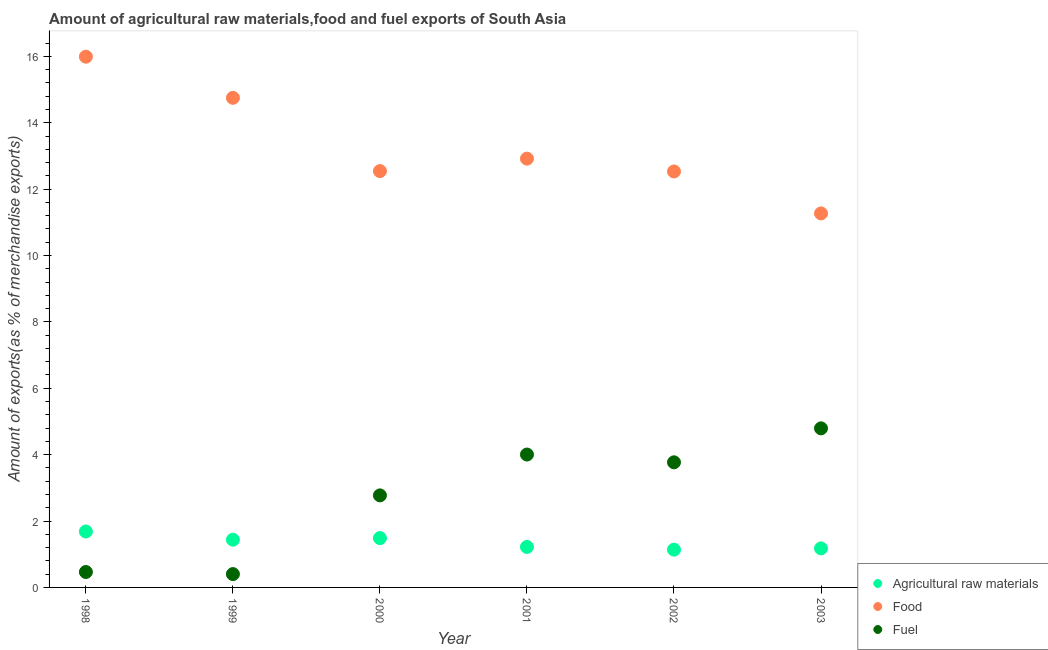Is the number of dotlines equal to the number of legend labels?
Offer a terse response. Yes. What is the percentage of raw materials exports in 2003?
Keep it short and to the point. 1.18. Across all years, what is the maximum percentage of fuel exports?
Provide a succinct answer. 4.79. Across all years, what is the minimum percentage of raw materials exports?
Give a very brief answer. 1.14. In which year was the percentage of fuel exports maximum?
Your response must be concise. 2003. In which year was the percentage of food exports minimum?
Your answer should be compact. 2003. What is the total percentage of raw materials exports in the graph?
Make the answer very short. 8.14. What is the difference between the percentage of food exports in 1998 and that in 2000?
Your response must be concise. 3.45. What is the difference between the percentage of fuel exports in 2001 and the percentage of food exports in 1999?
Your response must be concise. -10.75. What is the average percentage of food exports per year?
Give a very brief answer. 13.33. In the year 2000, what is the difference between the percentage of food exports and percentage of raw materials exports?
Your answer should be very brief. 11.06. In how many years, is the percentage of food exports greater than 14 %?
Keep it short and to the point. 2. What is the ratio of the percentage of fuel exports in 1998 to that in 2000?
Offer a very short reply. 0.17. Is the difference between the percentage of food exports in 1998 and 2001 greater than the difference between the percentage of fuel exports in 1998 and 2001?
Provide a short and direct response. Yes. What is the difference between the highest and the second highest percentage of raw materials exports?
Keep it short and to the point. 0.2. What is the difference between the highest and the lowest percentage of fuel exports?
Make the answer very short. 4.39. In how many years, is the percentage of raw materials exports greater than the average percentage of raw materials exports taken over all years?
Ensure brevity in your answer.  3. Is the sum of the percentage of raw materials exports in 2001 and 2002 greater than the maximum percentage of fuel exports across all years?
Make the answer very short. No. Is it the case that in every year, the sum of the percentage of raw materials exports and percentage of food exports is greater than the percentage of fuel exports?
Your answer should be very brief. Yes. Is the percentage of food exports strictly greater than the percentage of raw materials exports over the years?
Your answer should be very brief. Yes. Is the percentage of fuel exports strictly less than the percentage of food exports over the years?
Your answer should be very brief. Yes. How many dotlines are there?
Provide a succinct answer. 3. How many years are there in the graph?
Provide a short and direct response. 6. What is the difference between two consecutive major ticks on the Y-axis?
Provide a succinct answer. 2. Are the values on the major ticks of Y-axis written in scientific E-notation?
Your answer should be compact. No. Does the graph contain any zero values?
Provide a succinct answer. No. Where does the legend appear in the graph?
Provide a succinct answer. Bottom right. How many legend labels are there?
Provide a short and direct response. 3. What is the title of the graph?
Your answer should be very brief. Amount of agricultural raw materials,food and fuel exports of South Asia. What is the label or title of the Y-axis?
Your answer should be very brief. Amount of exports(as % of merchandise exports). What is the Amount of exports(as % of merchandise exports) in Agricultural raw materials in 1998?
Your response must be concise. 1.68. What is the Amount of exports(as % of merchandise exports) of Food in 1998?
Keep it short and to the point. 15.99. What is the Amount of exports(as % of merchandise exports) of Fuel in 1998?
Provide a succinct answer. 0.46. What is the Amount of exports(as % of merchandise exports) in Agricultural raw materials in 1999?
Provide a short and direct response. 1.44. What is the Amount of exports(as % of merchandise exports) of Food in 1999?
Your answer should be compact. 14.75. What is the Amount of exports(as % of merchandise exports) in Fuel in 1999?
Offer a very short reply. 0.4. What is the Amount of exports(as % of merchandise exports) of Agricultural raw materials in 2000?
Offer a terse response. 1.49. What is the Amount of exports(as % of merchandise exports) in Food in 2000?
Provide a succinct answer. 12.54. What is the Amount of exports(as % of merchandise exports) in Fuel in 2000?
Ensure brevity in your answer.  2.77. What is the Amount of exports(as % of merchandise exports) in Agricultural raw materials in 2001?
Your answer should be very brief. 1.22. What is the Amount of exports(as % of merchandise exports) of Food in 2001?
Your answer should be very brief. 12.92. What is the Amount of exports(as % of merchandise exports) of Fuel in 2001?
Provide a succinct answer. 4. What is the Amount of exports(as % of merchandise exports) of Agricultural raw materials in 2002?
Offer a very short reply. 1.14. What is the Amount of exports(as % of merchandise exports) in Food in 2002?
Make the answer very short. 12.53. What is the Amount of exports(as % of merchandise exports) in Fuel in 2002?
Ensure brevity in your answer.  3.77. What is the Amount of exports(as % of merchandise exports) in Agricultural raw materials in 2003?
Your answer should be very brief. 1.18. What is the Amount of exports(as % of merchandise exports) of Food in 2003?
Offer a very short reply. 11.27. What is the Amount of exports(as % of merchandise exports) in Fuel in 2003?
Keep it short and to the point. 4.79. Across all years, what is the maximum Amount of exports(as % of merchandise exports) in Agricultural raw materials?
Provide a short and direct response. 1.68. Across all years, what is the maximum Amount of exports(as % of merchandise exports) of Food?
Offer a very short reply. 15.99. Across all years, what is the maximum Amount of exports(as % of merchandise exports) in Fuel?
Your answer should be compact. 4.79. Across all years, what is the minimum Amount of exports(as % of merchandise exports) of Agricultural raw materials?
Offer a terse response. 1.14. Across all years, what is the minimum Amount of exports(as % of merchandise exports) in Food?
Keep it short and to the point. 11.27. Across all years, what is the minimum Amount of exports(as % of merchandise exports) in Fuel?
Ensure brevity in your answer.  0.4. What is the total Amount of exports(as % of merchandise exports) in Agricultural raw materials in the graph?
Keep it short and to the point. 8.14. What is the total Amount of exports(as % of merchandise exports) of Food in the graph?
Make the answer very short. 80. What is the total Amount of exports(as % of merchandise exports) in Fuel in the graph?
Provide a short and direct response. 16.2. What is the difference between the Amount of exports(as % of merchandise exports) of Agricultural raw materials in 1998 and that in 1999?
Your answer should be compact. 0.25. What is the difference between the Amount of exports(as % of merchandise exports) in Food in 1998 and that in 1999?
Make the answer very short. 1.24. What is the difference between the Amount of exports(as % of merchandise exports) in Fuel in 1998 and that in 1999?
Keep it short and to the point. 0.06. What is the difference between the Amount of exports(as % of merchandise exports) of Agricultural raw materials in 1998 and that in 2000?
Make the answer very short. 0.2. What is the difference between the Amount of exports(as % of merchandise exports) in Food in 1998 and that in 2000?
Make the answer very short. 3.45. What is the difference between the Amount of exports(as % of merchandise exports) in Fuel in 1998 and that in 2000?
Give a very brief answer. -2.31. What is the difference between the Amount of exports(as % of merchandise exports) in Agricultural raw materials in 1998 and that in 2001?
Ensure brevity in your answer.  0.47. What is the difference between the Amount of exports(as % of merchandise exports) of Food in 1998 and that in 2001?
Give a very brief answer. 3.07. What is the difference between the Amount of exports(as % of merchandise exports) of Fuel in 1998 and that in 2001?
Your response must be concise. -3.54. What is the difference between the Amount of exports(as % of merchandise exports) of Agricultural raw materials in 1998 and that in 2002?
Ensure brevity in your answer.  0.55. What is the difference between the Amount of exports(as % of merchandise exports) in Food in 1998 and that in 2002?
Ensure brevity in your answer.  3.46. What is the difference between the Amount of exports(as % of merchandise exports) of Fuel in 1998 and that in 2002?
Offer a terse response. -3.3. What is the difference between the Amount of exports(as % of merchandise exports) of Agricultural raw materials in 1998 and that in 2003?
Provide a succinct answer. 0.51. What is the difference between the Amount of exports(as % of merchandise exports) in Food in 1998 and that in 2003?
Give a very brief answer. 4.72. What is the difference between the Amount of exports(as % of merchandise exports) of Fuel in 1998 and that in 2003?
Your answer should be compact. -4.33. What is the difference between the Amount of exports(as % of merchandise exports) of Agricultural raw materials in 1999 and that in 2000?
Provide a succinct answer. -0.05. What is the difference between the Amount of exports(as % of merchandise exports) of Food in 1999 and that in 2000?
Keep it short and to the point. 2.21. What is the difference between the Amount of exports(as % of merchandise exports) of Fuel in 1999 and that in 2000?
Offer a terse response. -2.37. What is the difference between the Amount of exports(as % of merchandise exports) in Agricultural raw materials in 1999 and that in 2001?
Make the answer very short. 0.22. What is the difference between the Amount of exports(as % of merchandise exports) in Food in 1999 and that in 2001?
Keep it short and to the point. 1.83. What is the difference between the Amount of exports(as % of merchandise exports) of Fuel in 1999 and that in 2001?
Ensure brevity in your answer.  -3.6. What is the difference between the Amount of exports(as % of merchandise exports) of Agricultural raw materials in 1999 and that in 2002?
Keep it short and to the point. 0.3. What is the difference between the Amount of exports(as % of merchandise exports) of Food in 1999 and that in 2002?
Provide a short and direct response. 2.22. What is the difference between the Amount of exports(as % of merchandise exports) in Fuel in 1999 and that in 2002?
Ensure brevity in your answer.  -3.37. What is the difference between the Amount of exports(as % of merchandise exports) in Agricultural raw materials in 1999 and that in 2003?
Provide a short and direct response. 0.26. What is the difference between the Amount of exports(as % of merchandise exports) in Food in 1999 and that in 2003?
Provide a short and direct response. 3.48. What is the difference between the Amount of exports(as % of merchandise exports) of Fuel in 1999 and that in 2003?
Offer a very short reply. -4.39. What is the difference between the Amount of exports(as % of merchandise exports) of Agricultural raw materials in 2000 and that in 2001?
Ensure brevity in your answer.  0.27. What is the difference between the Amount of exports(as % of merchandise exports) of Food in 2000 and that in 2001?
Offer a very short reply. -0.37. What is the difference between the Amount of exports(as % of merchandise exports) of Fuel in 2000 and that in 2001?
Make the answer very short. -1.23. What is the difference between the Amount of exports(as % of merchandise exports) in Agricultural raw materials in 2000 and that in 2002?
Make the answer very short. 0.35. What is the difference between the Amount of exports(as % of merchandise exports) of Food in 2000 and that in 2002?
Provide a short and direct response. 0.01. What is the difference between the Amount of exports(as % of merchandise exports) of Fuel in 2000 and that in 2002?
Make the answer very short. -1. What is the difference between the Amount of exports(as % of merchandise exports) in Agricultural raw materials in 2000 and that in 2003?
Keep it short and to the point. 0.31. What is the difference between the Amount of exports(as % of merchandise exports) of Food in 2000 and that in 2003?
Offer a terse response. 1.28. What is the difference between the Amount of exports(as % of merchandise exports) in Fuel in 2000 and that in 2003?
Ensure brevity in your answer.  -2.02. What is the difference between the Amount of exports(as % of merchandise exports) of Agricultural raw materials in 2001 and that in 2002?
Give a very brief answer. 0.08. What is the difference between the Amount of exports(as % of merchandise exports) in Food in 2001 and that in 2002?
Offer a terse response. 0.39. What is the difference between the Amount of exports(as % of merchandise exports) in Fuel in 2001 and that in 2002?
Your response must be concise. 0.23. What is the difference between the Amount of exports(as % of merchandise exports) of Agricultural raw materials in 2001 and that in 2003?
Provide a short and direct response. 0.04. What is the difference between the Amount of exports(as % of merchandise exports) in Food in 2001 and that in 2003?
Provide a short and direct response. 1.65. What is the difference between the Amount of exports(as % of merchandise exports) of Fuel in 2001 and that in 2003?
Keep it short and to the point. -0.79. What is the difference between the Amount of exports(as % of merchandise exports) in Agricultural raw materials in 2002 and that in 2003?
Offer a terse response. -0.04. What is the difference between the Amount of exports(as % of merchandise exports) in Food in 2002 and that in 2003?
Offer a terse response. 1.26. What is the difference between the Amount of exports(as % of merchandise exports) in Fuel in 2002 and that in 2003?
Your response must be concise. -1.02. What is the difference between the Amount of exports(as % of merchandise exports) of Agricultural raw materials in 1998 and the Amount of exports(as % of merchandise exports) of Food in 1999?
Your response must be concise. -13.07. What is the difference between the Amount of exports(as % of merchandise exports) of Agricultural raw materials in 1998 and the Amount of exports(as % of merchandise exports) of Fuel in 1999?
Your answer should be very brief. 1.28. What is the difference between the Amount of exports(as % of merchandise exports) of Food in 1998 and the Amount of exports(as % of merchandise exports) of Fuel in 1999?
Provide a succinct answer. 15.59. What is the difference between the Amount of exports(as % of merchandise exports) in Agricultural raw materials in 1998 and the Amount of exports(as % of merchandise exports) in Food in 2000?
Provide a succinct answer. -10.86. What is the difference between the Amount of exports(as % of merchandise exports) of Agricultural raw materials in 1998 and the Amount of exports(as % of merchandise exports) of Fuel in 2000?
Offer a very short reply. -1.09. What is the difference between the Amount of exports(as % of merchandise exports) of Food in 1998 and the Amount of exports(as % of merchandise exports) of Fuel in 2000?
Provide a short and direct response. 13.22. What is the difference between the Amount of exports(as % of merchandise exports) of Agricultural raw materials in 1998 and the Amount of exports(as % of merchandise exports) of Food in 2001?
Your answer should be very brief. -11.23. What is the difference between the Amount of exports(as % of merchandise exports) in Agricultural raw materials in 1998 and the Amount of exports(as % of merchandise exports) in Fuel in 2001?
Give a very brief answer. -2.32. What is the difference between the Amount of exports(as % of merchandise exports) in Food in 1998 and the Amount of exports(as % of merchandise exports) in Fuel in 2001?
Give a very brief answer. 11.99. What is the difference between the Amount of exports(as % of merchandise exports) of Agricultural raw materials in 1998 and the Amount of exports(as % of merchandise exports) of Food in 2002?
Keep it short and to the point. -10.85. What is the difference between the Amount of exports(as % of merchandise exports) in Agricultural raw materials in 1998 and the Amount of exports(as % of merchandise exports) in Fuel in 2002?
Your answer should be very brief. -2.08. What is the difference between the Amount of exports(as % of merchandise exports) of Food in 1998 and the Amount of exports(as % of merchandise exports) of Fuel in 2002?
Offer a very short reply. 12.22. What is the difference between the Amount of exports(as % of merchandise exports) of Agricultural raw materials in 1998 and the Amount of exports(as % of merchandise exports) of Food in 2003?
Provide a succinct answer. -9.58. What is the difference between the Amount of exports(as % of merchandise exports) of Agricultural raw materials in 1998 and the Amount of exports(as % of merchandise exports) of Fuel in 2003?
Your response must be concise. -3.11. What is the difference between the Amount of exports(as % of merchandise exports) in Food in 1998 and the Amount of exports(as % of merchandise exports) in Fuel in 2003?
Offer a very short reply. 11.2. What is the difference between the Amount of exports(as % of merchandise exports) of Agricultural raw materials in 1999 and the Amount of exports(as % of merchandise exports) of Food in 2000?
Make the answer very short. -11.1. What is the difference between the Amount of exports(as % of merchandise exports) in Agricultural raw materials in 1999 and the Amount of exports(as % of merchandise exports) in Fuel in 2000?
Offer a terse response. -1.33. What is the difference between the Amount of exports(as % of merchandise exports) in Food in 1999 and the Amount of exports(as % of merchandise exports) in Fuel in 2000?
Provide a succinct answer. 11.98. What is the difference between the Amount of exports(as % of merchandise exports) of Agricultural raw materials in 1999 and the Amount of exports(as % of merchandise exports) of Food in 2001?
Provide a short and direct response. -11.48. What is the difference between the Amount of exports(as % of merchandise exports) of Agricultural raw materials in 1999 and the Amount of exports(as % of merchandise exports) of Fuel in 2001?
Offer a very short reply. -2.56. What is the difference between the Amount of exports(as % of merchandise exports) in Food in 1999 and the Amount of exports(as % of merchandise exports) in Fuel in 2001?
Make the answer very short. 10.75. What is the difference between the Amount of exports(as % of merchandise exports) of Agricultural raw materials in 1999 and the Amount of exports(as % of merchandise exports) of Food in 2002?
Offer a terse response. -11.09. What is the difference between the Amount of exports(as % of merchandise exports) of Agricultural raw materials in 1999 and the Amount of exports(as % of merchandise exports) of Fuel in 2002?
Provide a short and direct response. -2.33. What is the difference between the Amount of exports(as % of merchandise exports) of Food in 1999 and the Amount of exports(as % of merchandise exports) of Fuel in 2002?
Provide a succinct answer. 10.98. What is the difference between the Amount of exports(as % of merchandise exports) of Agricultural raw materials in 1999 and the Amount of exports(as % of merchandise exports) of Food in 2003?
Provide a short and direct response. -9.83. What is the difference between the Amount of exports(as % of merchandise exports) in Agricultural raw materials in 1999 and the Amount of exports(as % of merchandise exports) in Fuel in 2003?
Your answer should be compact. -3.35. What is the difference between the Amount of exports(as % of merchandise exports) in Food in 1999 and the Amount of exports(as % of merchandise exports) in Fuel in 2003?
Provide a succinct answer. 9.96. What is the difference between the Amount of exports(as % of merchandise exports) in Agricultural raw materials in 2000 and the Amount of exports(as % of merchandise exports) in Food in 2001?
Offer a terse response. -11.43. What is the difference between the Amount of exports(as % of merchandise exports) of Agricultural raw materials in 2000 and the Amount of exports(as % of merchandise exports) of Fuel in 2001?
Offer a very short reply. -2.52. What is the difference between the Amount of exports(as % of merchandise exports) in Food in 2000 and the Amount of exports(as % of merchandise exports) in Fuel in 2001?
Provide a short and direct response. 8.54. What is the difference between the Amount of exports(as % of merchandise exports) of Agricultural raw materials in 2000 and the Amount of exports(as % of merchandise exports) of Food in 2002?
Provide a short and direct response. -11.05. What is the difference between the Amount of exports(as % of merchandise exports) of Agricultural raw materials in 2000 and the Amount of exports(as % of merchandise exports) of Fuel in 2002?
Provide a succinct answer. -2.28. What is the difference between the Amount of exports(as % of merchandise exports) in Food in 2000 and the Amount of exports(as % of merchandise exports) in Fuel in 2002?
Provide a succinct answer. 8.77. What is the difference between the Amount of exports(as % of merchandise exports) in Agricultural raw materials in 2000 and the Amount of exports(as % of merchandise exports) in Food in 2003?
Provide a succinct answer. -9.78. What is the difference between the Amount of exports(as % of merchandise exports) of Agricultural raw materials in 2000 and the Amount of exports(as % of merchandise exports) of Fuel in 2003?
Your response must be concise. -3.31. What is the difference between the Amount of exports(as % of merchandise exports) in Food in 2000 and the Amount of exports(as % of merchandise exports) in Fuel in 2003?
Offer a very short reply. 7.75. What is the difference between the Amount of exports(as % of merchandise exports) of Agricultural raw materials in 2001 and the Amount of exports(as % of merchandise exports) of Food in 2002?
Keep it short and to the point. -11.31. What is the difference between the Amount of exports(as % of merchandise exports) in Agricultural raw materials in 2001 and the Amount of exports(as % of merchandise exports) in Fuel in 2002?
Offer a very short reply. -2.55. What is the difference between the Amount of exports(as % of merchandise exports) in Food in 2001 and the Amount of exports(as % of merchandise exports) in Fuel in 2002?
Make the answer very short. 9.15. What is the difference between the Amount of exports(as % of merchandise exports) in Agricultural raw materials in 2001 and the Amount of exports(as % of merchandise exports) in Food in 2003?
Ensure brevity in your answer.  -10.05. What is the difference between the Amount of exports(as % of merchandise exports) in Agricultural raw materials in 2001 and the Amount of exports(as % of merchandise exports) in Fuel in 2003?
Give a very brief answer. -3.57. What is the difference between the Amount of exports(as % of merchandise exports) in Food in 2001 and the Amount of exports(as % of merchandise exports) in Fuel in 2003?
Your response must be concise. 8.13. What is the difference between the Amount of exports(as % of merchandise exports) of Agricultural raw materials in 2002 and the Amount of exports(as % of merchandise exports) of Food in 2003?
Provide a short and direct response. -10.13. What is the difference between the Amount of exports(as % of merchandise exports) in Agricultural raw materials in 2002 and the Amount of exports(as % of merchandise exports) in Fuel in 2003?
Offer a terse response. -3.65. What is the difference between the Amount of exports(as % of merchandise exports) in Food in 2002 and the Amount of exports(as % of merchandise exports) in Fuel in 2003?
Provide a succinct answer. 7.74. What is the average Amount of exports(as % of merchandise exports) of Agricultural raw materials per year?
Provide a short and direct response. 1.36. What is the average Amount of exports(as % of merchandise exports) in Food per year?
Ensure brevity in your answer.  13.33. What is the average Amount of exports(as % of merchandise exports) in Fuel per year?
Offer a terse response. 2.7. In the year 1998, what is the difference between the Amount of exports(as % of merchandise exports) in Agricultural raw materials and Amount of exports(as % of merchandise exports) in Food?
Make the answer very short. -14.3. In the year 1998, what is the difference between the Amount of exports(as % of merchandise exports) of Agricultural raw materials and Amount of exports(as % of merchandise exports) of Fuel?
Provide a succinct answer. 1.22. In the year 1998, what is the difference between the Amount of exports(as % of merchandise exports) of Food and Amount of exports(as % of merchandise exports) of Fuel?
Your answer should be very brief. 15.52. In the year 1999, what is the difference between the Amount of exports(as % of merchandise exports) of Agricultural raw materials and Amount of exports(as % of merchandise exports) of Food?
Your answer should be compact. -13.31. In the year 1999, what is the difference between the Amount of exports(as % of merchandise exports) of Agricultural raw materials and Amount of exports(as % of merchandise exports) of Fuel?
Provide a succinct answer. 1.04. In the year 1999, what is the difference between the Amount of exports(as % of merchandise exports) of Food and Amount of exports(as % of merchandise exports) of Fuel?
Your answer should be compact. 14.35. In the year 2000, what is the difference between the Amount of exports(as % of merchandise exports) in Agricultural raw materials and Amount of exports(as % of merchandise exports) in Food?
Offer a terse response. -11.06. In the year 2000, what is the difference between the Amount of exports(as % of merchandise exports) in Agricultural raw materials and Amount of exports(as % of merchandise exports) in Fuel?
Make the answer very short. -1.29. In the year 2000, what is the difference between the Amount of exports(as % of merchandise exports) in Food and Amount of exports(as % of merchandise exports) in Fuel?
Give a very brief answer. 9.77. In the year 2001, what is the difference between the Amount of exports(as % of merchandise exports) of Agricultural raw materials and Amount of exports(as % of merchandise exports) of Food?
Your answer should be very brief. -11.7. In the year 2001, what is the difference between the Amount of exports(as % of merchandise exports) in Agricultural raw materials and Amount of exports(as % of merchandise exports) in Fuel?
Offer a terse response. -2.78. In the year 2001, what is the difference between the Amount of exports(as % of merchandise exports) in Food and Amount of exports(as % of merchandise exports) in Fuel?
Your response must be concise. 8.91. In the year 2002, what is the difference between the Amount of exports(as % of merchandise exports) of Agricultural raw materials and Amount of exports(as % of merchandise exports) of Food?
Give a very brief answer. -11.39. In the year 2002, what is the difference between the Amount of exports(as % of merchandise exports) of Agricultural raw materials and Amount of exports(as % of merchandise exports) of Fuel?
Offer a terse response. -2.63. In the year 2002, what is the difference between the Amount of exports(as % of merchandise exports) of Food and Amount of exports(as % of merchandise exports) of Fuel?
Your answer should be compact. 8.76. In the year 2003, what is the difference between the Amount of exports(as % of merchandise exports) in Agricultural raw materials and Amount of exports(as % of merchandise exports) in Food?
Give a very brief answer. -10.09. In the year 2003, what is the difference between the Amount of exports(as % of merchandise exports) in Agricultural raw materials and Amount of exports(as % of merchandise exports) in Fuel?
Offer a very short reply. -3.62. In the year 2003, what is the difference between the Amount of exports(as % of merchandise exports) of Food and Amount of exports(as % of merchandise exports) of Fuel?
Give a very brief answer. 6.48. What is the ratio of the Amount of exports(as % of merchandise exports) in Agricultural raw materials in 1998 to that in 1999?
Your response must be concise. 1.17. What is the ratio of the Amount of exports(as % of merchandise exports) of Food in 1998 to that in 1999?
Ensure brevity in your answer.  1.08. What is the ratio of the Amount of exports(as % of merchandise exports) of Fuel in 1998 to that in 1999?
Make the answer very short. 1.16. What is the ratio of the Amount of exports(as % of merchandise exports) in Agricultural raw materials in 1998 to that in 2000?
Your response must be concise. 1.13. What is the ratio of the Amount of exports(as % of merchandise exports) in Food in 1998 to that in 2000?
Your response must be concise. 1.27. What is the ratio of the Amount of exports(as % of merchandise exports) of Fuel in 1998 to that in 2000?
Your response must be concise. 0.17. What is the ratio of the Amount of exports(as % of merchandise exports) of Agricultural raw materials in 1998 to that in 2001?
Offer a very short reply. 1.38. What is the ratio of the Amount of exports(as % of merchandise exports) in Food in 1998 to that in 2001?
Give a very brief answer. 1.24. What is the ratio of the Amount of exports(as % of merchandise exports) in Fuel in 1998 to that in 2001?
Your answer should be very brief. 0.12. What is the ratio of the Amount of exports(as % of merchandise exports) of Agricultural raw materials in 1998 to that in 2002?
Provide a short and direct response. 1.48. What is the ratio of the Amount of exports(as % of merchandise exports) in Food in 1998 to that in 2002?
Provide a succinct answer. 1.28. What is the ratio of the Amount of exports(as % of merchandise exports) in Fuel in 1998 to that in 2002?
Your answer should be compact. 0.12. What is the ratio of the Amount of exports(as % of merchandise exports) of Agricultural raw materials in 1998 to that in 2003?
Give a very brief answer. 1.43. What is the ratio of the Amount of exports(as % of merchandise exports) of Food in 1998 to that in 2003?
Keep it short and to the point. 1.42. What is the ratio of the Amount of exports(as % of merchandise exports) of Fuel in 1998 to that in 2003?
Keep it short and to the point. 0.1. What is the ratio of the Amount of exports(as % of merchandise exports) of Agricultural raw materials in 1999 to that in 2000?
Your answer should be compact. 0.97. What is the ratio of the Amount of exports(as % of merchandise exports) in Food in 1999 to that in 2000?
Offer a very short reply. 1.18. What is the ratio of the Amount of exports(as % of merchandise exports) in Fuel in 1999 to that in 2000?
Offer a very short reply. 0.14. What is the ratio of the Amount of exports(as % of merchandise exports) of Agricultural raw materials in 1999 to that in 2001?
Provide a succinct answer. 1.18. What is the ratio of the Amount of exports(as % of merchandise exports) in Food in 1999 to that in 2001?
Give a very brief answer. 1.14. What is the ratio of the Amount of exports(as % of merchandise exports) of Fuel in 1999 to that in 2001?
Your answer should be very brief. 0.1. What is the ratio of the Amount of exports(as % of merchandise exports) in Agricultural raw materials in 1999 to that in 2002?
Provide a succinct answer. 1.26. What is the ratio of the Amount of exports(as % of merchandise exports) of Food in 1999 to that in 2002?
Ensure brevity in your answer.  1.18. What is the ratio of the Amount of exports(as % of merchandise exports) in Fuel in 1999 to that in 2002?
Offer a very short reply. 0.11. What is the ratio of the Amount of exports(as % of merchandise exports) in Agricultural raw materials in 1999 to that in 2003?
Ensure brevity in your answer.  1.22. What is the ratio of the Amount of exports(as % of merchandise exports) in Food in 1999 to that in 2003?
Make the answer very short. 1.31. What is the ratio of the Amount of exports(as % of merchandise exports) in Fuel in 1999 to that in 2003?
Provide a short and direct response. 0.08. What is the ratio of the Amount of exports(as % of merchandise exports) of Agricultural raw materials in 2000 to that in 2001?
Provide a short and direct response. 1.22. What is the ratio of the Amount of exports(as % of merchandise exports) in Food in 2000 to that in 2001?
Provide a succinct answer. 0.97. What is the ratio of the Amount of exports(as % of merchandise exports) in Fuel in 2000 to that in 2001?
Keep it short and to the point. 0.69. What is the ratio of the Amount of exports(as % of merchandise exports) of Agricultural raw materials in 2000 to that in 2002?
Make the answer very short. 1.31. What is the ratio of the Amount of exports(as % of merchandise exports) in Fuel in 2000 to that in 2002?
Your answer should be compact. 0.74. What is the ratio of the Amount of exports(as % of merchandise exports) in Agricultural raw materials in 2000 to that in 2003?
Make the answer very short. 1.26. What is the ratio of the Amount of exports(as % of merchandise exports) in Food in 2000 to that in 2003?
Provide a succinct answer. 1.11. What is the ratio of the Amount of exports(as % of merchandise exports) in Fuel in 2000 to that in 2003?
Give a very brief answer. 0.58. What is the ratio of the Amount of exports(as % of merchandise exports) of Agricultural raw materials in 2001 to that in 2002?
Give a very brief answer. 1.07. What is the ratio of the Amount of exports(as % of merchandise exports) in Food in 2001 to that in 2002?
Your answer should be compact. 1.03. What is the ratio of the Amount of exports(as % of merchandise exports) in Fuel in 2001 to that in 2002?
Your response must be concise. 1.06. What is the ratio of the Amount of exports(as % of merchandise exports) of Agricultural raw materials in 2001 to that in 2003?
Your answer should be compact. 1.04. What is the ratio of the Amount of exports(as % of merchandise exports) of Food in 2001 to that in 2003?
Offer a terse response. 1.15. What is the ratio of the Amount of exports(as % of merchandise exports) in Fuel in 2001 to that in 2003?
Offer a terse response. 0.84. What is the ratio of the Amount of exports(as % of merchandise exports) of Food in 2002 to that in 2003?
Your answer should be very brief. 1.11. What is the ratio of the Amount of exports(as % of merchandise exports) of Fuel in 2002 to that in 2003?
Your response must be concise. 0.79. What is the difference between the highest and the second highest Amount of exports(as % of merchandise exports) of Agricultural raw materials?
Provide a succinct answer. 0.2. What is the difference between the highest and the second highest Amount of exports(as % of merchandise exports) of Food?
Ensure brevity in your answer.  1.24. What is the difference between the highest and the second highest Amount of exports(as % of merchandise exports) of Fuel?
Offer a very short reply. 0.79. What is the difference between the highest and the lowest Amount of exports(as % of merchandise exports) in Agricultural raw materials?
Provide a succinct answer. 0.55. What is the difference between the highest and the lowest Amount of exports(as % of merchandise exports) of Food?
Your response must be concise. 4.72. What is the difference between the highest and the lowest Amount of exports(as % of merchandise exports) in Fuel?
Your response must be concise. 4.39. 